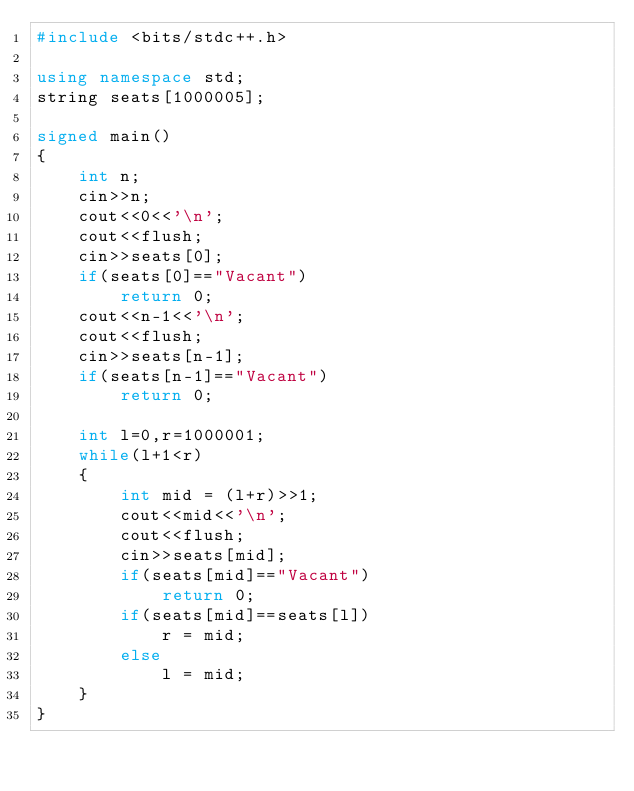Convert code to text. <code><loc_0><loc_0><loc_500><loc_500><_C++_>#include <bits/stdc++.h>

using namespace std;
string seats[1000005];

signed main()
{
    int n;
    cin>>n;
    cout<<0<<'\n';
    cout<<flush;
    cin>>seats[0];
    if(seats[0]=="Vacant")
        return 0;
    cout<<n-1<<'\n';
    cout<<flush;
    cin>>seats[n-1];
    if(seats[n-1]=="Vacant")
        return 0;
    
    int l=0,r=1000001;
    while(l+1<r)
    {
        int mid = (l+r)>>1;
        cout<<mid<<'\n';
        cout<<flush;
        cin>>seats[mid];
        if(seats[mid]=="Vacant")
            return 0;
        if(seats[mid]==seats[l])
            r = mid;
        else
            l = mid;
    }
}</code> 